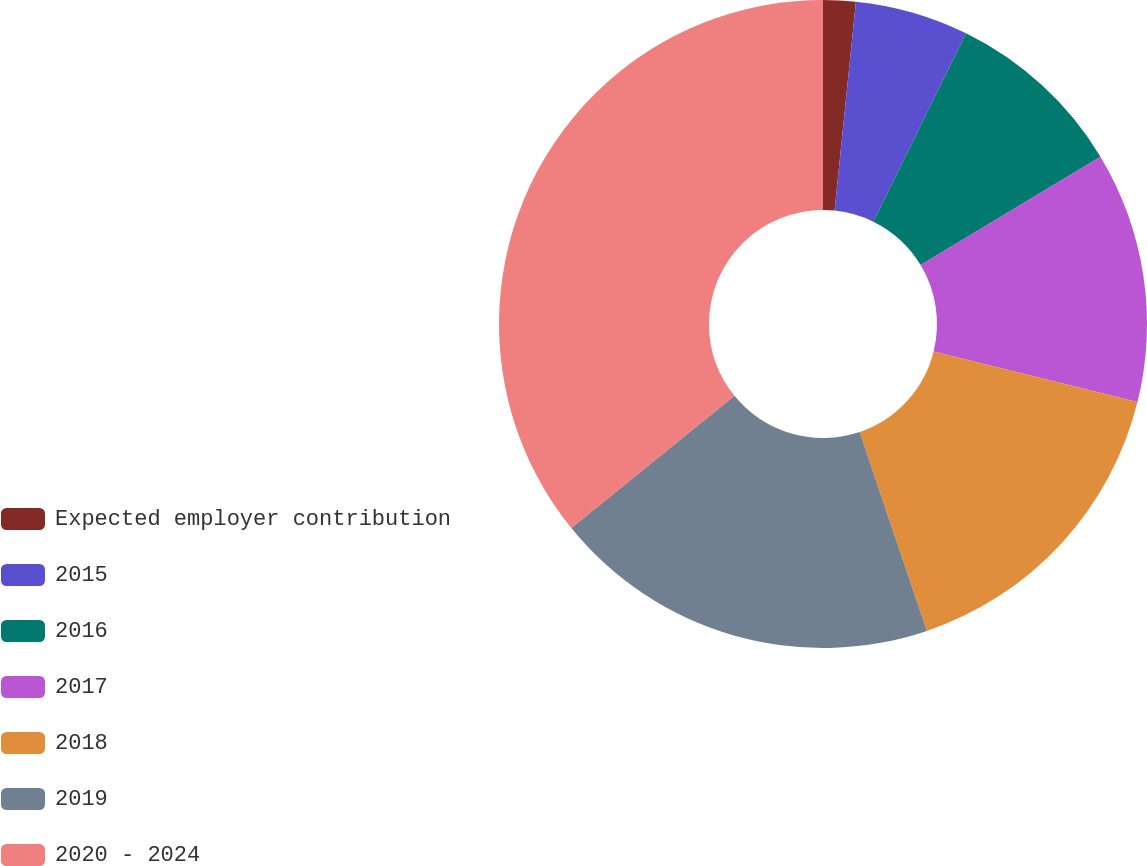<chart> <loc_0><loc_0><loc_500><loc_500><pie_chart><fcel>Expected employer contribution<fcel>2015<fcel>2016<fcel>2017<fcel>2018<fcel>2019<fcel>2020 - 2024<nl><fcel>1.62%<fcel>5.66%<fcel>9.08%<fcel>12.51%<fcel>15.93%<fcel>19.35%<fcel>35.84%<nl></chart> 